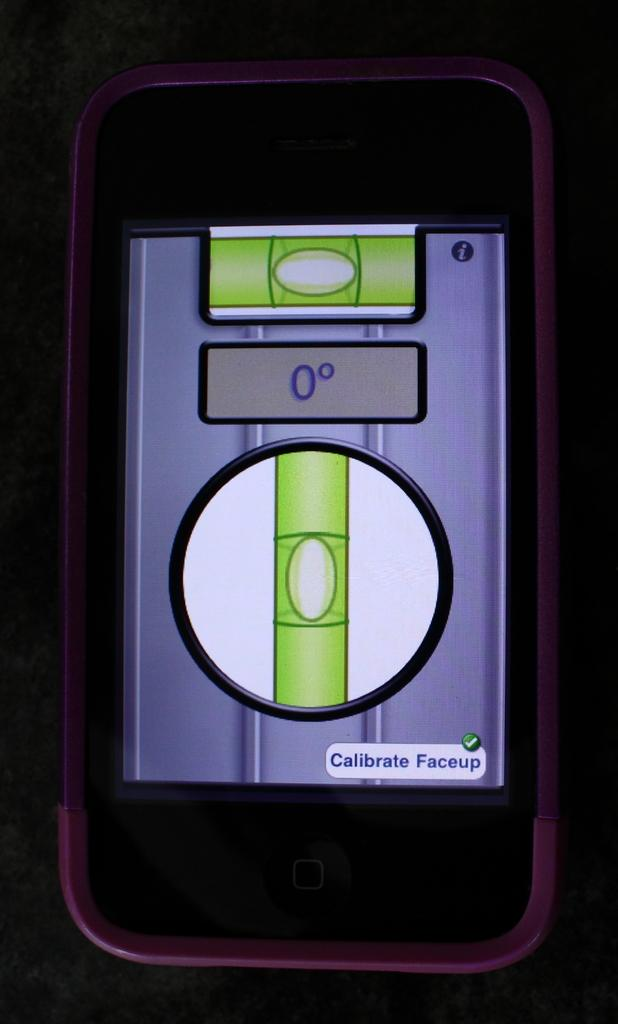<image>
Provide a brief description of the given image. The smart phone displays the message Calibrate Faceup on the bottom of the screen. 